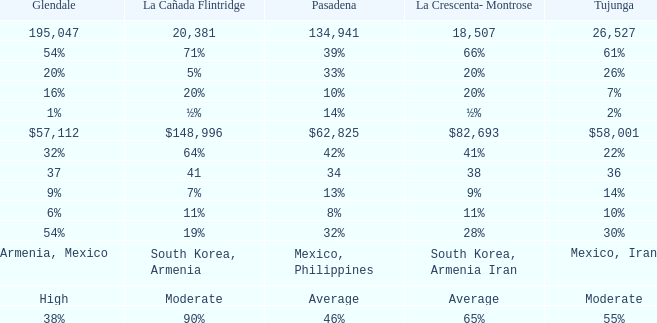What is the figure for Pasadena when Tujunga is 36? 34.0. Parse the table in full. {'header': ['Glendale', 'La Cañada Flintridge', 'Pasadena', 'La Crescenta- Montrose', 'Tujunga'], 'rows': [['195,047', '20,381', '134,941', '18,507', '26,527'], ['54%', '71%', '39%', '66%', '61%'], ['20%', '5%', '33%', '20%', '26%'], ['16%', '20%', '10%', '20%', '7%'], ['1%', '½%', '14%', '½%', '2%'], ['$57,112', '$148,996', '$62,825', '$82,693', '$58,001'], ['32%', '64%', '42%', '41%', '22%'], ['37', '41', '34', '38', '36'], ['9%', '7%', '13%', '9%', '14%'], ['6%', '11%', '8%', '11%', '10%'], ['54%', '19%', '32%', '28%', '30%'], ['Armenia, Mexico', 'South Korea, Armenia', 'Mexico, Philippines', 'South Korea, Armenia Iran', 'Mexico, Iran'], ['High', 'Moderate', 'Average', 'Average', 'Moderate'], ['38%', '90%', '46%', '65%', '55%']]} 